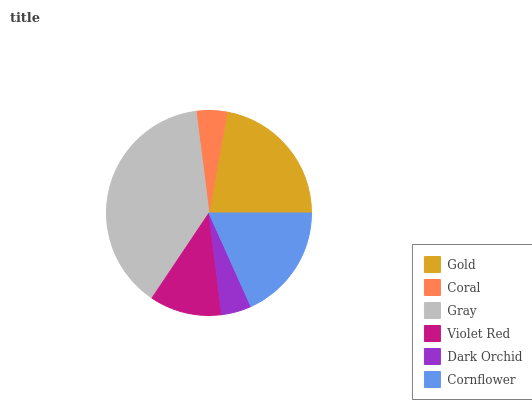Is Dark Orchid the minimum?
Answer yes or no. Yes. Is Gray the maximum?
Answer yes or no. Yes. Is Coral the minimum?
Answer yes or no. No. Is Coral the maximum?
Answer yes or no. No. Is Gold greater than Coral?
Answer yes or no. Yes. Is Coral less than Gold?
Answer yes or no. Yes. Is Coral greater than Gold?
Answer yes or no. No. Is Gold less than Coral?
Answer yes or no. No. Is Cornflower the high median?
Answer yes or no. Yes. Is Violet Red the low median?
Answer yes or no. Yes. Is Violet Red the high median?
Answer yes or no. No. Is Gold the low median?
Answer yes or no. No. 